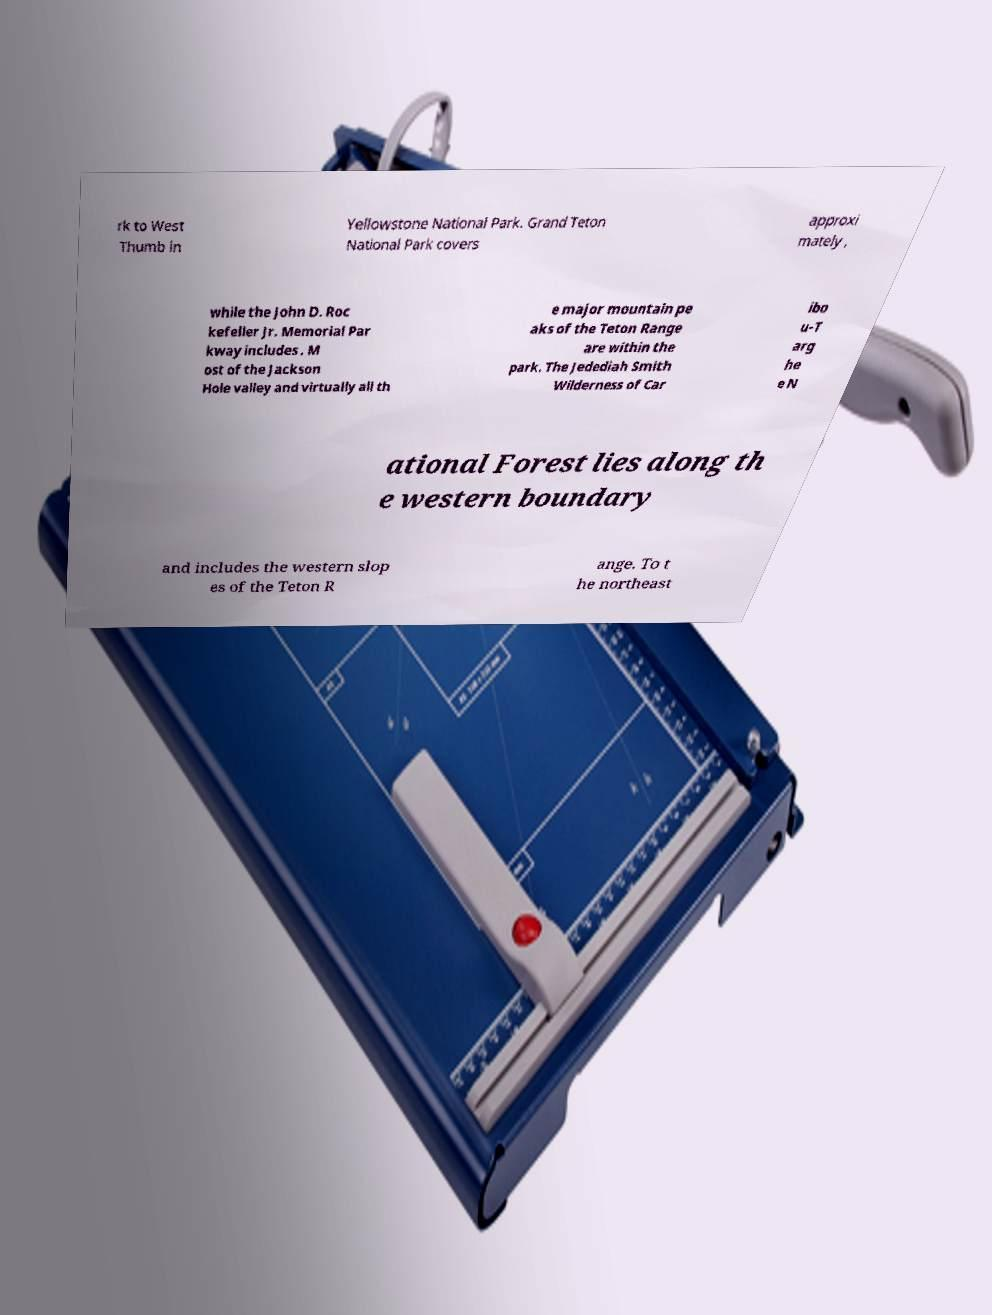Please identify and transcribe the text found in this image. rk to West Thumb in Yellowstone National Park. Grand Teton National Park covers approxi mately , while the John D. Roc kefeller Jr. Memorial Par kway includes . M ost of the Jackson Hole valley and virtually all th e major mountain pe aks of the Teton Range are within the park. The Jedediah Smith Wilderness of Car ibo u-T arg he e N ational Forest lies along th e western boundary and includes the western slop es of the Teton R ange. To t he northeast 